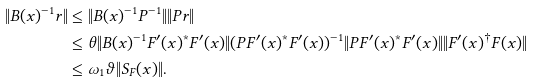Convert formula to latex. <formula><loc_0><loc_0><loc_500><loc_500>\| B ( x ) ^ { - 1 } { r } \| & \leq \| B ( x ) ^ { - 1 } P ^ { - 1 } \| \| P { r } \| \\ & \leq \theta \| B ( x ) ^ { - 1 } F ^ { \prime } ( x ) ^ { * } F ^ { \prime } ( x ) \| ( P F ^ { \prime } ( x ) ^ { * } F ^ { \prime } ( x ) ) ^ { - 1 } \| P F ^ { \prime } ( x ) ^ { * } F ^ { \prime } ( x ) \| \| F ^ { \prime } ( x ) ^ { \dagger } F ( x ) \| \\ & \leq \omega _ { 1 } \vartheta \| S _ { F } ( x ) \| .</formula> 